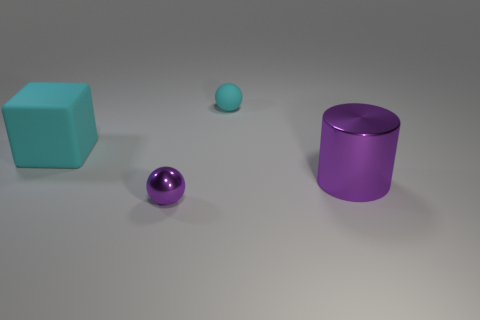Add 3 cyan rubber cubes. How many objects exist? 7 Subtract all cubes. How many objects are left? 3 Add 2 small cyan rubber balls. How many small cyan rubber balls are left? 3 Add 1 tiny rubber spheres. How many tiny rubber spheres exist? 2 Subtract 0 yellow cylinders. How many objects are left? 4 Subtract all large rubber objects. Subtract all small cyan objects. How many objects are left? 2 